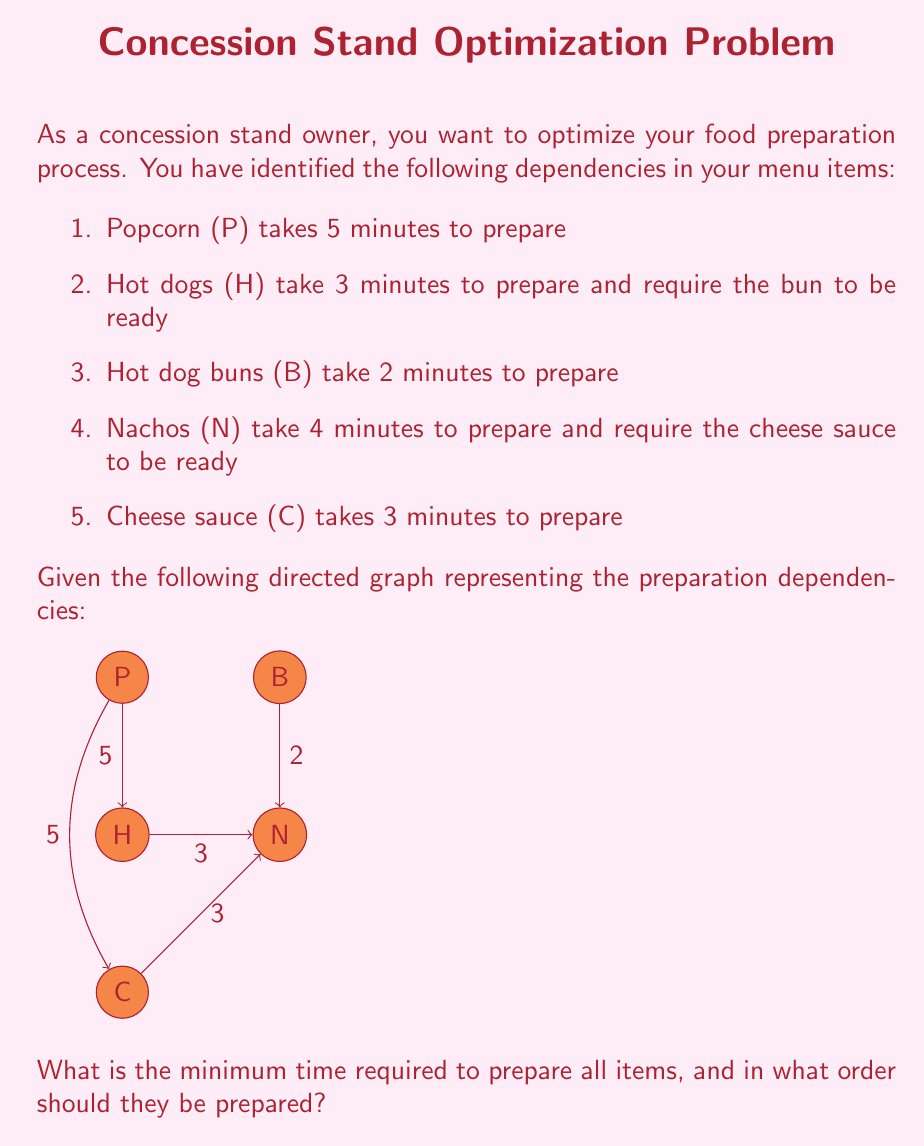Can you solve this math problem? To solve this problem, we'll use the concept of topological sorting and critical path analysis in directed acyclic graphs (DAG).

Step 1: Identify the topological order
The topological order gives us a valid sequence of preparation:
P, B, C, H, N

Step 2: Calculate earliest start times
Let $ES(x)$ be the earliest start time for item $x$.
$ES(P) = 0$
$ES(B) = 0$
$ES(C) = 0$
$ES(H) = \max(ES(B) + 2, ES(P) + 5) = 5$
$ES(N) = \max(ES(C) + 3, ES(P) + 5) = 5$

Step 3: Calculate earliest finish times
Let $EF(x)$ be the earliest finish time for item $x$.
$EF(P) = ES(P) + 5 = 5$
$EF(B) = ES(B) + 2 = 2$
$EF(C) = ES(C) + 3 = 3$
$EF(H) = ES(H) + 3 = 8$
$EF(N) = ES(N) + 4 = 9$

Step 4: Identify the critical path
The critical path is the longest path through the graph, which determines the minimum time required. In this case, it's P → N, with a total time of 9 minutes.

Step 5: Determine the optimal preparation order
To minimize idle time, we should start items as soon as their dependencies are met:

1. Start P and B simultaneously (t = 0)
2. Start C when B is finished (t = 2)
3. Start H when P is finished (t = 5)
4. Start N when P and C are finished (t = 5)

This order ensures that all items are prepared in the minimum possible time of 9 minutes.
Answer: 9 minutes; Order: P&B → C → H&N 